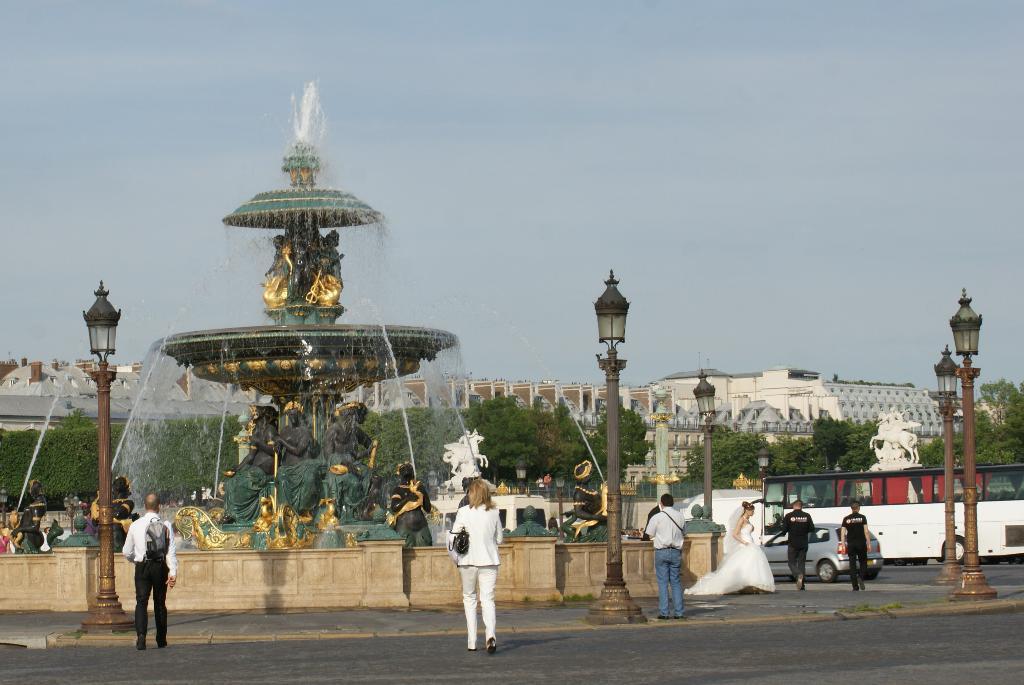Please provide a concise description of this image. In the center of the image, we can see a fountain and in the background, there are lights and we can see people, some are wearing bags and there is a bride and we can see trees, poles and buildings. At the top, there is sky and at the bottom, there is a road. 